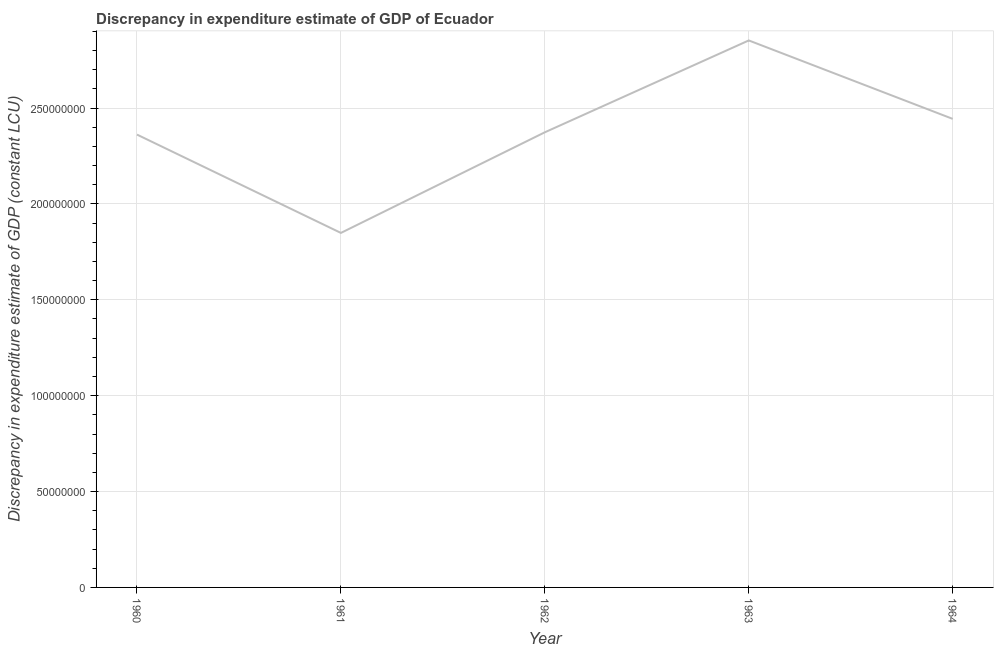What is the discrepancy in expenditure estimate of gdp in 1963?
Your response must be concise. 2.85e+08. Across all years, what is the maximum discrepancy in expenditure estimate of gdp?
Your response must be concise. 2.85e+08. Across all years, what is the minimum discrepancy in expenditure estimate of gdp?
Ensure brevity in your answer.  1.85e+08. In which year was the discrepancy in expenditure estimate of gdp maximum?
Provide a succinct answer. 1963. In which year was the discrepancy in expenditure estimate of gdp minimum?
Your answer should be very brief. 1961. What is the sum of the discrepancy in expenditure estimate of gdp?
Make the answer very short. 1.19e+09. What is the difference between the discrepancy in expenditure estimate of gdp in 1962 and 1963?
Your answer should be very brief. -4.79e+07. What is the average discrepancy in expenditure estimate of gdp per year?
Offer a terse response. 2.38e+08. What is the median discrepancy in expenditure estimate of gdp?
Keep it short and to the point. 2.37e+08. In how many years, is the discrepancy in expenditure estimate of gdp greater than 80000000 LCU?
Your answer should be compact. 5. Do a majority of the years between 1964 and 1960 (inclusive) have discrepancy in expenditure estimate of gdp greater than 150000000 LCU?
Your answer should be compact. Yes. What is the ratio of the discrepancy in expenditure estimate of gdp in 1961 to that in 1963?
Your answer should be very brief. 0.65. What is the difference between the highest and the second highest discrepancy in expenditure estimate of gdp?
Offer a terse response. 4.09e+07. What is the difference between the highest and the lowest discrepancy in expenditure estimate of gdp?
Give a very brief answer. 1.00e+08. In how many years, is the discrepancy in expenditure estimate of gdp greater than the average discrepancy in expenditure estimate of gdp taken over all years?
Ensure brevity in your answer.  2. How many years are there in the graph?
Your answer should be very brief. 5. What is the difference between two consecutive major ticks on the Y-axis?
Offer a terse response. 5.00e+07. Does the graph contain grids?
Provide a succinct answer. Yes. What is the title of the graph?
Offer a terse response. Discrepancy in expenditure estimate of GDP of Ecuador. What is the label or title of the Y-axis?
Offer a very short reply. Discrepancy in expenditure estimate of GDP (constant LCU). What is the Discrepancy in expenditure estimate of GDP (constant LCU) of 1960?
Make the answer very short. 2.36e+08. What is the Discrepancy in expenditure estimate of GDP (constant LCU) of 1961?
Give a very brief answer. 1.85e+08. What is the Discrepancy in expenditure estimate of GDP (constant LCU) of 1962?
Your answer should be very brief. 2.37e+08. What is the Discrepancy in expenditure estimate of GDP (constant LCU) in 1963?
Keep it short and to the point. 2.85e+08. What is the Discrepancy in expenditure estimate of GDP (constant LCU) of 1964?
Ensure brevity in your answer.  2.44e+08. What is the difference between the Discrepancy in expenditure estimate of GDP (constant LCU) in 1960 and 1961?
Your response must be concise. 5.13e+07. What is the difference between the Discrepancy in expenditure estimate of GDP (constant LCU) in 1960 and 1962?
Give a very brief answer. -1.19e+06. What is the difference between the Discrepancy in expenditure estimate of GDP (constant LCU) in 1960 and 1963?
Make the answer very short. -4.91e+07. What is the difference between the Discrepancy in expenditure estimate of GDP (constant LCU) in 1960 and 1964?
Ensure brevity in your answer.  -8.18e+06. What is the difference between the Discrepancy in expenditure estimate of GDP (constant LCU) in 1961 and 1962?
Offer a terse response. -5.25e+07. What is the difference between the Discrepancy in expenditure estimate of GDP (constant LCU) in 1961 and 1963?
Provide a succinct answer. -1.00e+08. What is the difference between the Discrepancy in expenditure estimate of GDP (constant LCU) in 1961 and 1964?
Make the answer very short. -5.95e+07. What is the difference between the Discrepancy in expenditure estimate of GDP (constant LCU) in 1962 and 1963?
Make the answer very short. -4.79e+07. What is the difference between the Discrepancy in expenditure estimate of GDP (constant LCU) in 1962 and 1964?
Keep it short and to the point. -7.00e+06. What is the difference between the Discrepancy in expenditure estimate of GDP (constant LCU) in 1963 and 1964?
Offer a terse response. 4.09e+07. What is the ratio of the Discrepancy in expenditure estimate of GDP (constant LCU) in 1960 to that in 1961?
Give a very brief answer. 1.28. What is the ratio of the Discrepancy in expenditure estimate of GDP (constant LCU) in 1960 to that in 1962?
Provide a succinct answer. 0.99. What is the ratio of the Discrepancy in expenditure estimate of GDP (constant LCU) in 1960 to that in 1963?
Keep it short and to the point. 0.83. What is the ratio of the Discrepancy in expenditure estimate of GDP (constant LCU) in 1960 to that in 1964?
Provide a succinct answer. 0.97. What is the ratio of the Discrepancy in expenditure estimate of GDP (constant LCU) in 1961 to that in 1962?
Keep it short and to the point. 0.78. What is the ratio of the Discrepancy in expenditure estimate of GDP (constant LCU) in 1961 to that in 1963?
Your answer should be compact. 0.65. What is the ratio of the Discrepancy in expenditure estimate of GDP (constant LCU) in 1961 to that in 1964?
Your answer should be very brief. 0.76. What is the ratio of the Discrepancy in expenditure estimate of GDP (constant LCU) in 1962 to that in 1963?
Your answer should be very brief. 0.83. What is the ratio of the Discrepancy in expenditure estimate of GDP (constant LCU) in 1963 to that in 1964?
Offer a very short reply. 1.17. 